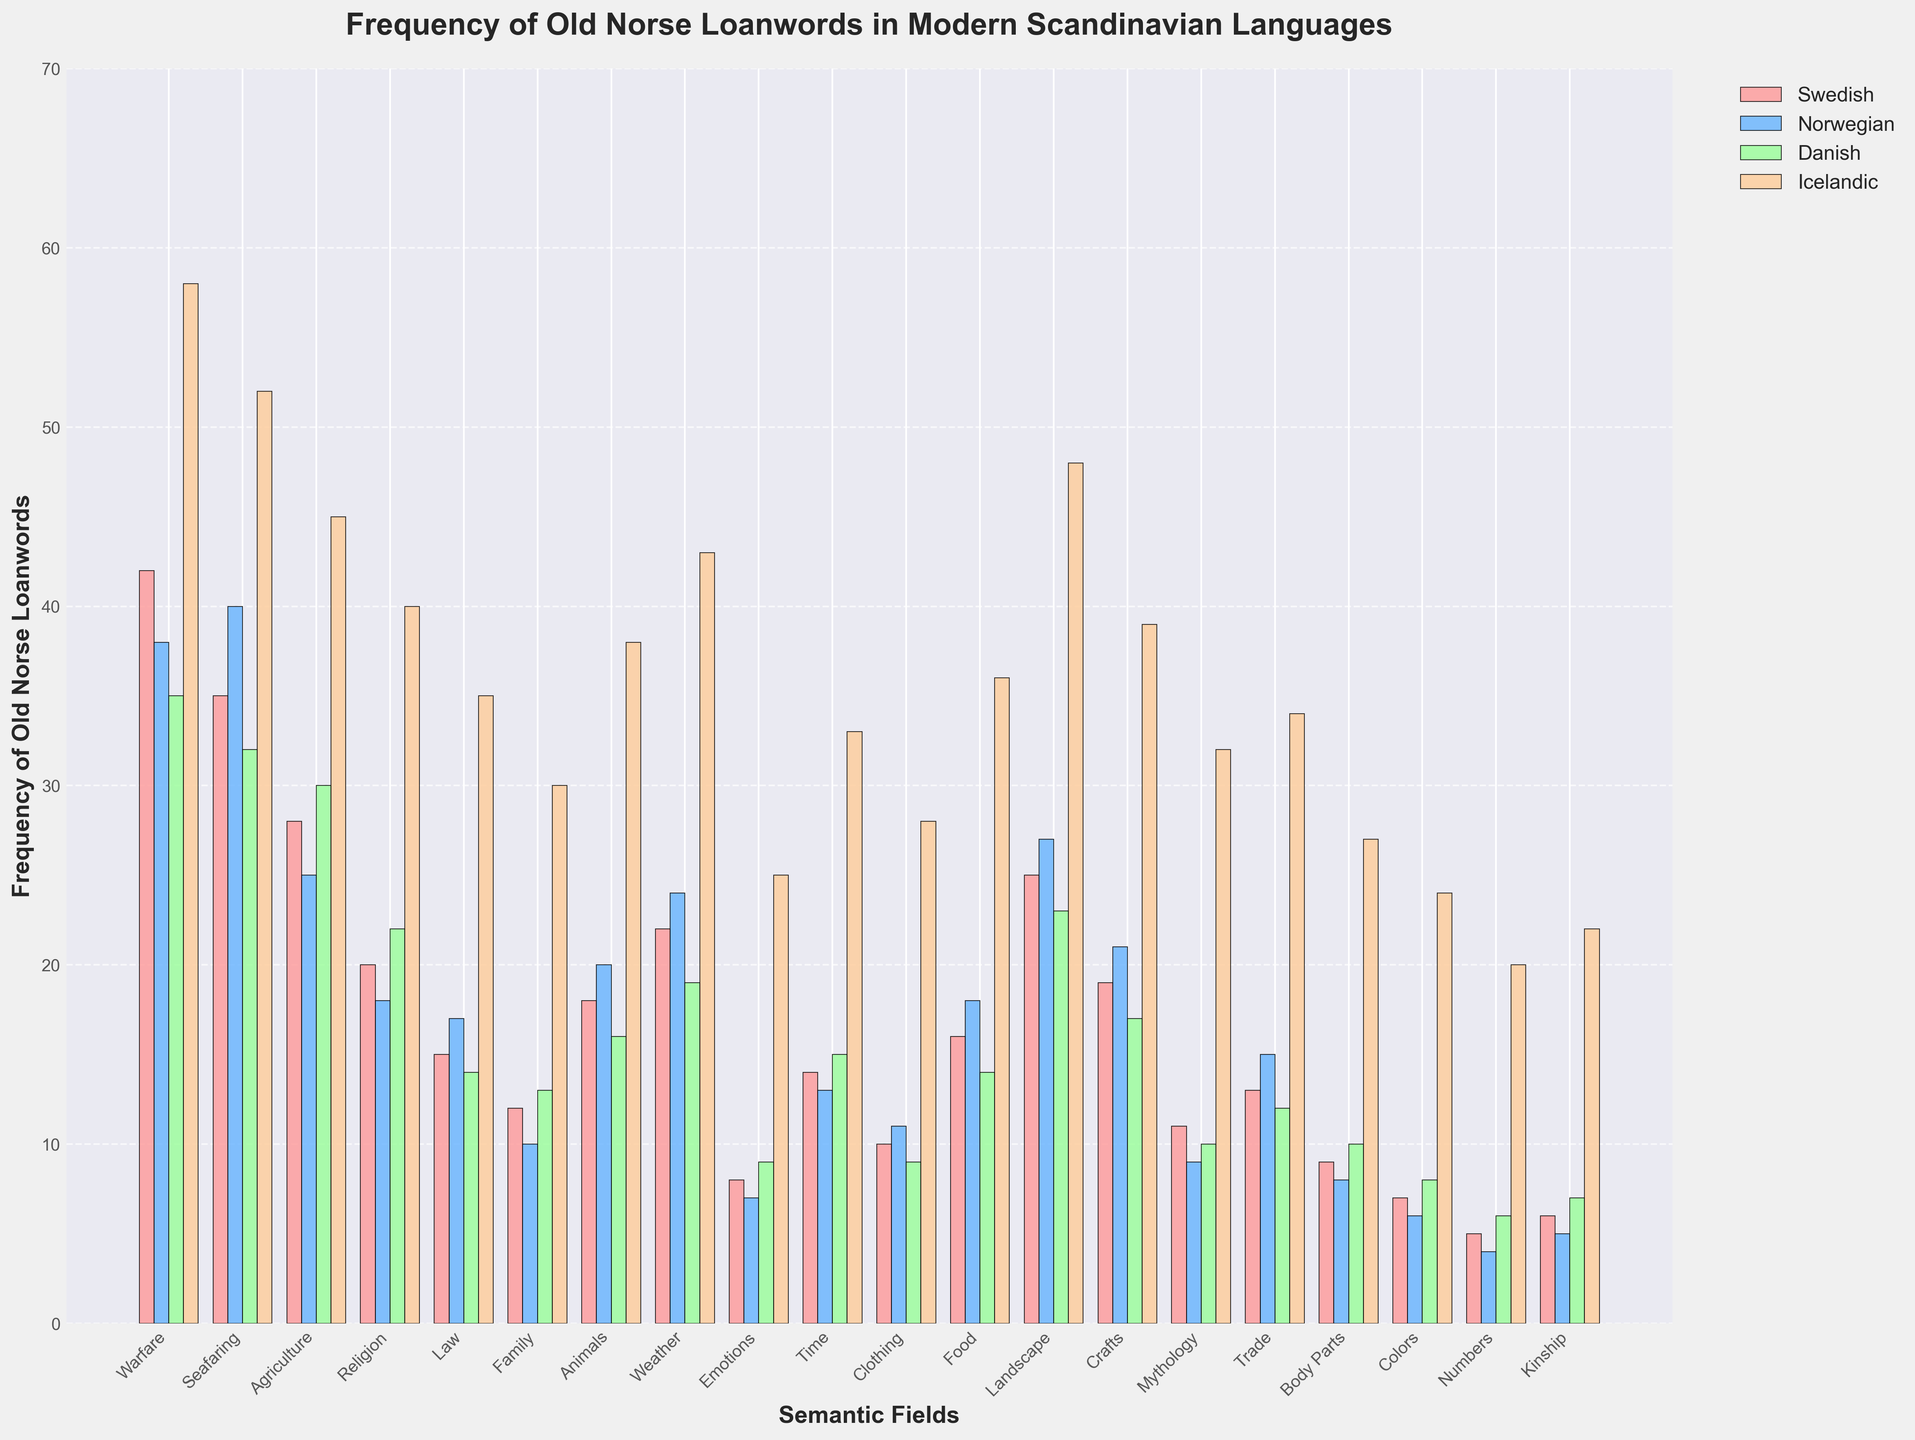Which semantic field has the highest frequency of Old Norse loanwords in Icelandic? The highest bar among the Icelandic semantic fields corresponds to the field "Warfare" using a specific color. Observing the heights of these bars, "Warfare" stands out as the tallest.
Answer: Warfare Which Scandinavian language has the least number of Old Norse loanwords in the field of Emotions? In the Emotions category, the shortest bar among the four languages represents Norwegian. Comparing the heights ensures this is correct.
Answer: Norwegian What is the combined frequency of Old Norse loanwords in the semantic field of Seafaring across all listed languages? Add the frequencies from the bars corresponding to Seafaring for Swedish (35), Norwegian (40), Danish (32), and Icelandic (52): 35 + 40 + 32 + 52 = 159.
Answer: 159 How many more Old Norse loanwords are there in the semantic field of Time in Icelandic compared to Danish? Subtract the number of loanwords in Danish (15) from Icelandic (33): 33 - 15 = 18.
Answer: 18 Does the semantic field of Agriculture have more Old Norse loanwords in Norwegian or Swedish? Compare the bar heights for the Agriculture field in Norwegian and Swedish: Swedish has a higher bar (28) than Norwegian (25).
Answer: Swedish Which semantic field shows the largest difference in the frequency of Old Norse loanwords between Swedish and Icelandic? Calculate the differences for each field. The largest difference appears between Icelandic and Swedish in the "Family" field: 30 - 12 = 18.
Answer: Family What is the total frequency of Old Norse loanwords in the fields Law and Family for Danish? Sum the frequencies for the Law (14) and Family (13) fields in Danish: 14 + 13 = 27.
Answer: 27 Which semantic field has approximately equal frequencies of Old Norse loanwords in Swedish and Danish? Identify the bars with similar heights. For the "Time" field, Swedish has 14 and Danish has 15 ensuring they are nearly equal.
Answer: Time In which semantic field does Norwegian have greater Old Norse loanwords compared to Swedish? Check the heights of Norwegian bars exceeding Swedish ones; "Seafaring" has Norwegian (40) surpassing Swedish (35).
Answer: Seafaring Which language has the highest frequency of Old Norse loanwords in the Mythology field? Identify the tallest bar within the Mythology category. Icelandic has the highest bar (32).
Answer: Icelandic 